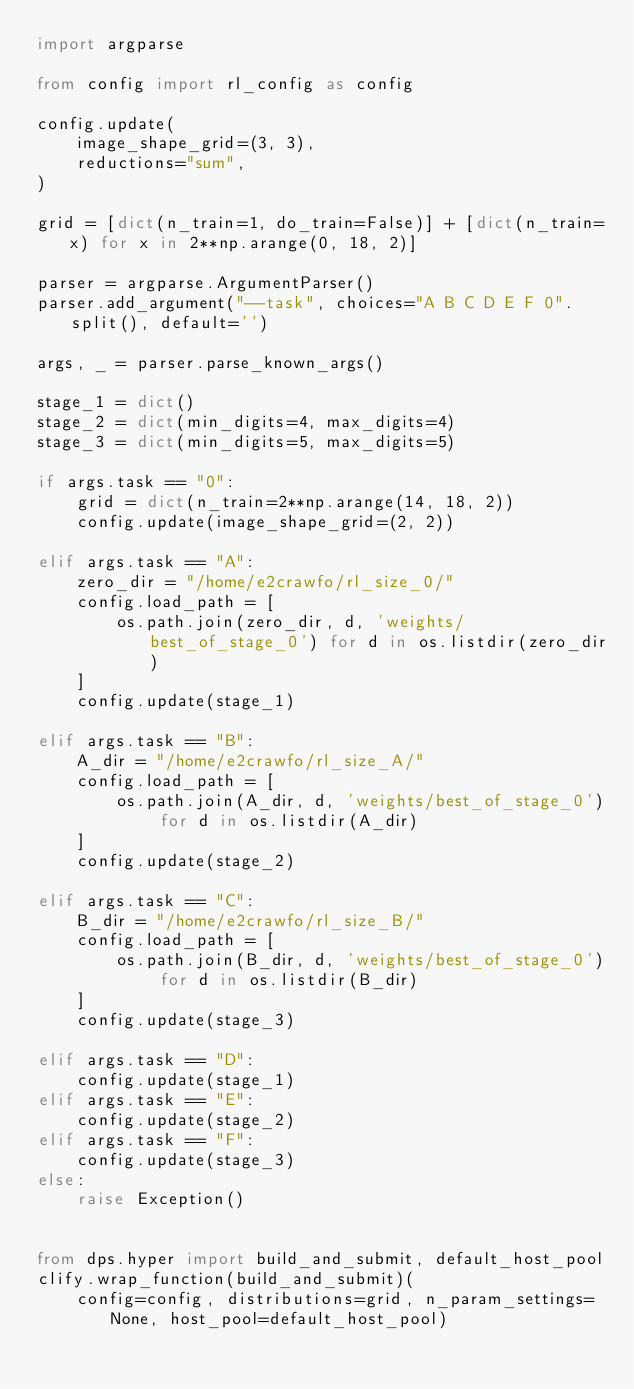Convert code to text. <code><loc_0><loc_0><loc_500><loc_500><_Python_>import argparse

from config import rl_config as config

config.update(
    image_shape_grid=(3, 3),
    reductions="sum",
)

grid = [dict(n_train=1, do_train=False)] + [dict(n_train=x) for x in 2**np.arange(0, 18, 2)]

parser = argparse.ArgumentParser()
parser.add_argument("--task", choices="A B C D E F 0".split(), default='')

args, _ = parser.parse_known_args()

stage_1 = dict()
stage_2 = dict(min_digits=4, max_digits=4)
stage_3 = dict(min_digits=5, max_digits=5)

if args.task == "0":
    grid = dict(n_train=2**np.arange(14, 18, 2))
    config.update(image_shape_grid=(2, 2))

elif args.task == "A":
    zero_dir = "/home/e2crawfo/rl_size_0/"
    config.load_path = [
        os.path.join(zero_dir, d, 'weights/best_of_stage_0') for d in os.listdir(zero_dir)
    ]
    config.update(stage_1)

elif args.task == "B":
    A_dir = "/home/e2crawfo/rl_size_A/"
    config.load_path = [
        os.path.join(A_dir, d, 'weights/best_of_stage_0') for d in os.listdir(A_dir)
    ]
    config.update(stage_2)

elif args.task == "C":
    B_dir = "/home/e2crawfo/rl_size_B/"
    config.load_path = [
        os.path.join(B_dir, d, 'weights/best_of_stage_0') for d in os.listdir(B_dir)
    ]
    config.update(stage_3)

elif args.task == "D":
    config.update(stage_1)
elif args.task == "E":
    config.update(stage_2)
elif args.task == "F":
    config.update(stage_3)
else:
    raise Exception()


from dps.hyper import build_and_submit, default_host_pool
clify.wrap_function(build_and_submit)(
    config=config, distributions=grid, n_param_settings=None, host_pool=default_host_pool)
</code> 